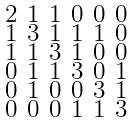<formula> <loc_0><loc_0><loc_500><loc_500>\begin{smallmatrix} 2 & 1 & 1 & 0 & 0 & 0 \\ 1 & 3 & 1 & 1 & 1 & 0 \\ 1 & 1 & 3 & 1 & 0 & 0 \\ 0 & 1 & 1 & 3 & 0 & 1 \\ 0 & 1 & 0 & 0 & 3 & 1 \\ 0 & 0 & 0 & 1 & 1 & 3 \end{smallmatrix}</formula> 